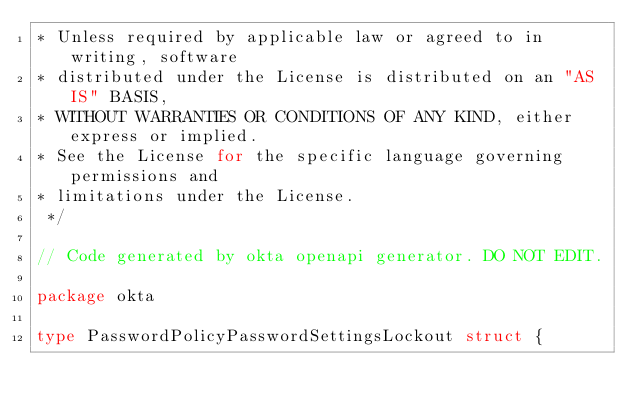<code> <loc_0><loc_0><loc_500><loc_500><_Go_>* Unless required by applicable law or agreed to in writing, software
* distributed under the License is distributed on an "AS IS" BASIS,
* WITHOUT WARRANTIES OR CONDITIONS OF ANY KIND, either express or implied.
* See the License for the specific language governing permissions and
* limitations under the License.
 */

// Code generated by okta openapi generator. DO NOT EDIT.

package okta

type PasswordPolicyPasswordSettingsLockout struct {</code> 